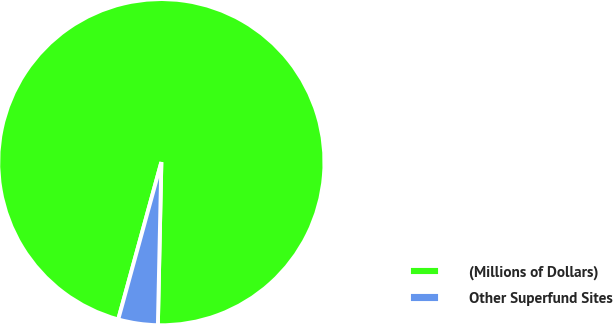Convert chart to OTSL. <chart><loc_0><loc_0><loc_500><loc_500><pie_chart><fcel>(Millions of Dollars)<fcel>Other Superfund Sites<nl><fcel>96.08%<fcel>3.92%<nl></chart> 